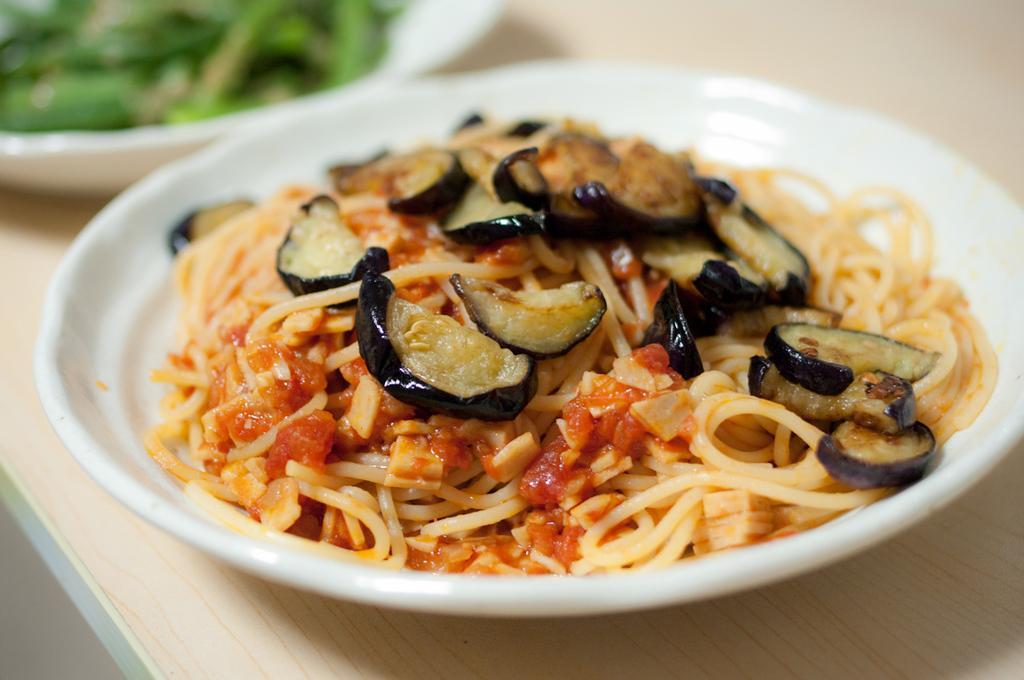In one or two sentences, can you explain what this image depicts? In this image, we can see food on the plate. At the bottom, we can see wooden surface. On the left side top of the image, we can see the blur view. Here we can see a bowl with some food. 